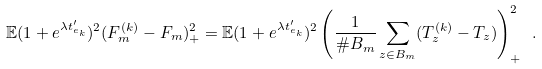Convert formula to latex. <formula><loc_0><loc_0><loc_500><loc_500>\mathbb { E } ( 1 + e ^ { \lambda t _ { e _ { k } } ^ { \prime } } ) ^ { 2 } ( F _ { m } ^ { ( k ) } - F _ { m } ) _ { + } ^ { 2 } = \mathbb { E } ( 1 + e ^ { \lambda t _ { e _ { k } } ^ { \prime } } ) ^ { 2 } \left ( \frac { 1 } { \# B _ { m } } \sum _ { z \in B _ { m } } ( T _ { z } ^ { ( k ) } - T _ { z } ) \right ) _ { + } ^ { 2 } \ .</formula> 